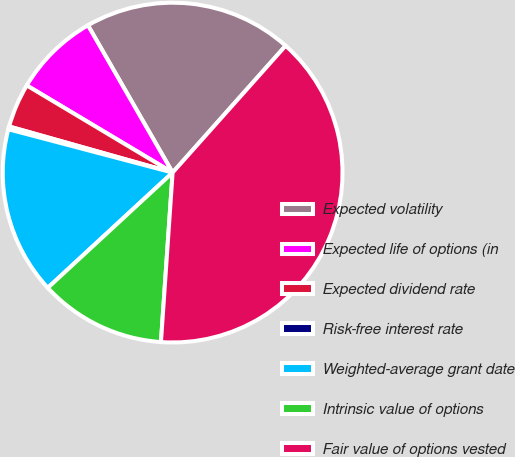Convert chart to OTSL. <chart><loc_0><loc_0><loc_500><loc_500><pie_chart><fcel>Expected volatility<fcel>Expected life of options (in<fcel>Expected dividend rate<fcel>Risk-free interest rate<fcel>Weighted-average grant date<fcel>Intrinsic value of options<fcel>Fair value of options vested<nl><fcel>19.89%<fcel>8.12%<fcel>4.2%<fcel>0.27%<fcel>15.97%<fcel>12.04%<fcel>39.51%<nl></chart> 